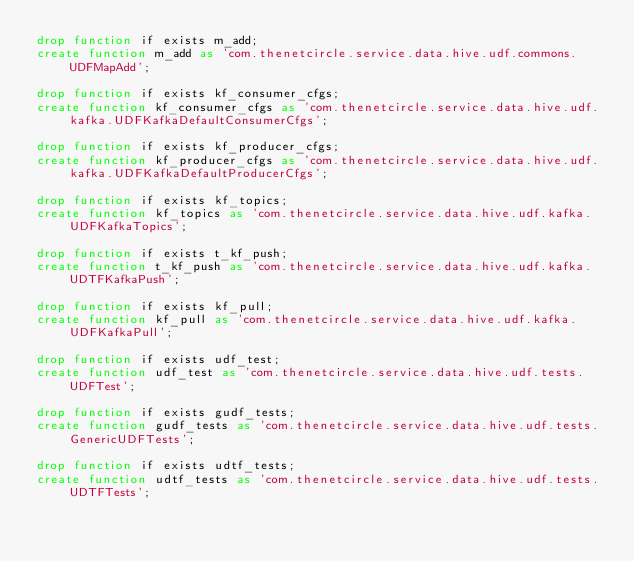Convert code to text. <code><loc_0><loc_0><loc_500><loc_500><_SQL_>drop function if exists m_add;
create function m_add as 'com.thenetcircle.service.data.hive.udf.commons.UDFMapAdd';

drop function if exists kf_consumer_cfgs;
create function kf_consumer_cfgs as 'com.thenetcircle.service.data.hive.udf.kafka.UDFKafkaDefaultConsumerCfgs';

drop function if exists kf_producer_cfgs;
create function kf_producer_cfgs as 'com.thenetcircle.service.data.hive.udf.kafka.UDFKafkaDefaultProducerCfgs';

drop function if exists kf_topics;
create function kf_topics as 'com.thenetcircle.service.data.hive.udf.kafka.UDFKafkaTopics';

drop function if exists t_kf_push;
create function t_kf_push as 'com.thenetcircle.service.data.hive.udf.kafka.UDTFKafkaPush';

drop function if exists kf_pull;
create function kf_pull as 'com.thenetcircle.service.data.hive.udf.kafka.UDFKafkaPull';

drop function if exists udf_test;
create function udf_test as 'com.thenetcircle.service.data.hive.udf.tests.UDFTest';

drop function if exists gudf_tests;
create function gudf_tests as 'com.thenetcircle.service.data.hive.udf.tests.GenericUDFTests';

drop function if exists udtf_tests;
create function udtf_tests as 'com.thenetcircle.service.data.hive.udf.tests.UDTFTests';</code> 